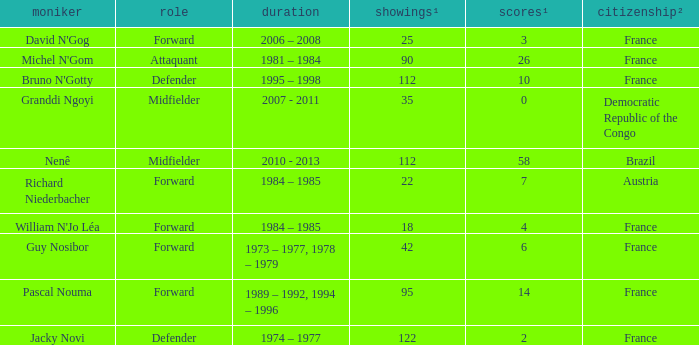How many players are from the country of Brazil? 1.0. 